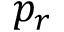Convert formula to latex. <formula><loc_0><loc_0><loc_500><loc_500>p _ { r }</formula> 